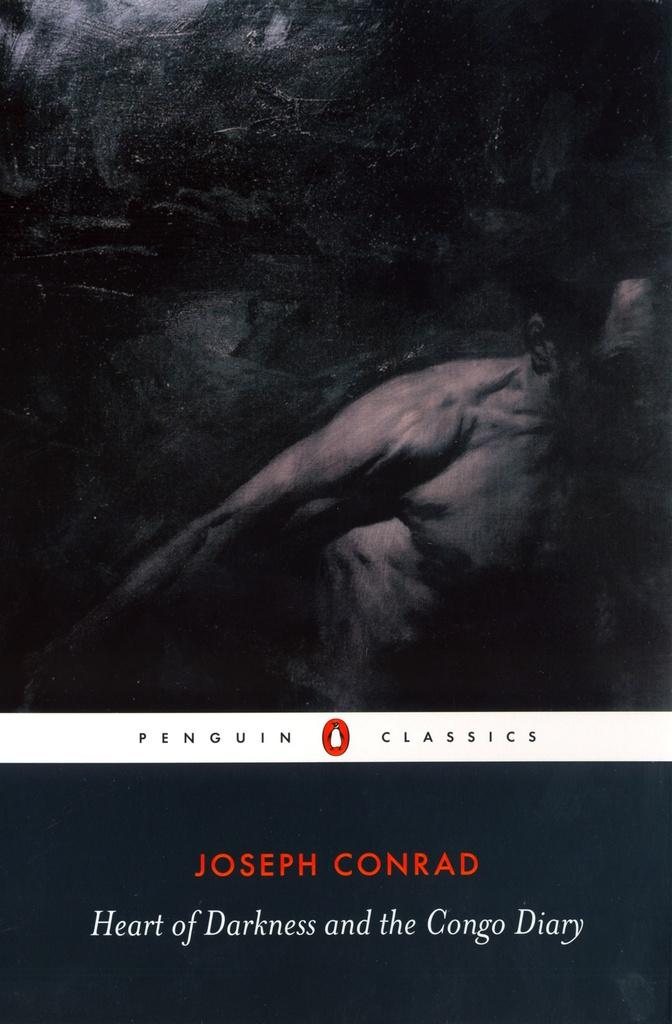What is the main subject of the image? The main subject of the image is a poster. How does the poster resemble another item? The poster resembles a book cover page. What is depicted on the poster? There is a picture of a person on the poster. What else is featured on the poster besides the image? There is text on the poster. Where is the judge sitting on the dock in the image? There is no judge or dock present in the image; it only features a poster with a picture of a person and text. 